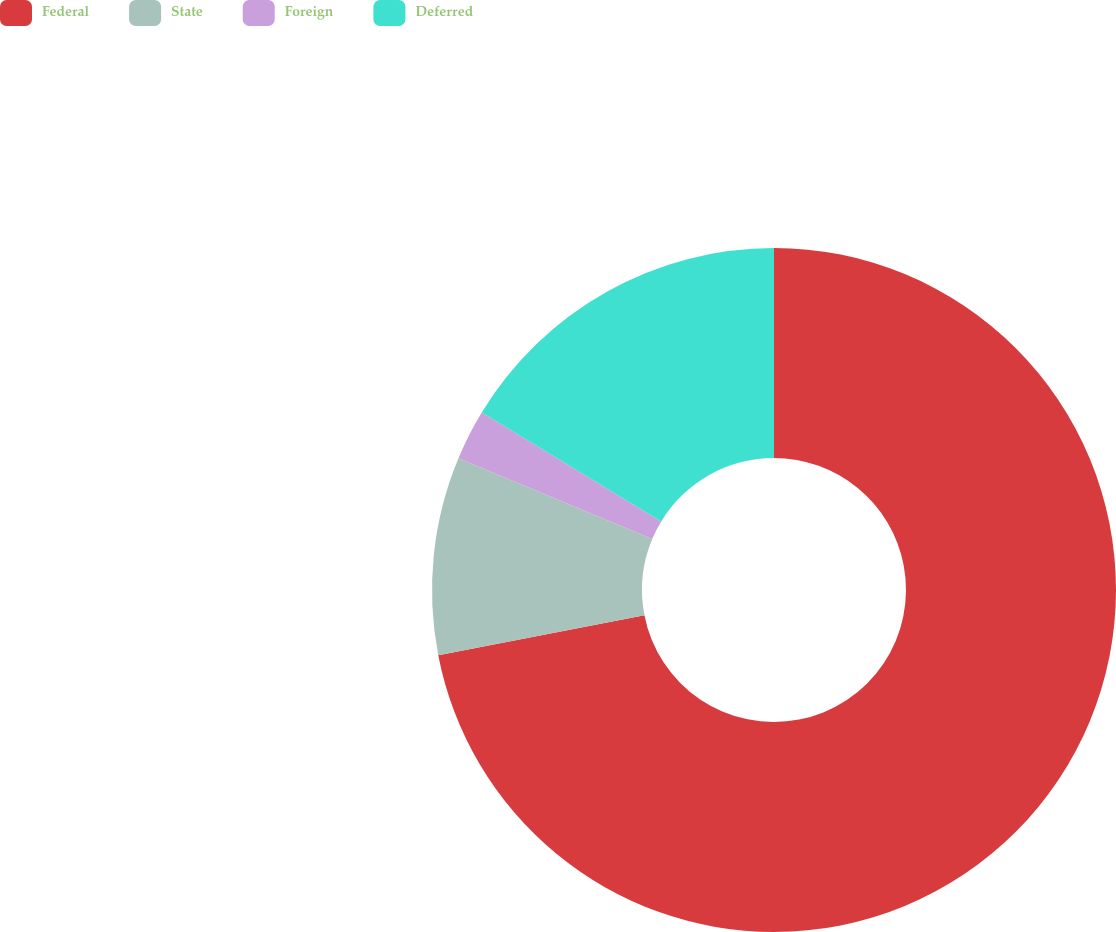Convert chart to OTSL. <chart><loc_0><loc_0><loc_500><loc_500><pie_chart><fcel>Federal<fcel>State<fcel>Foreign<fcel>Deferred<nl><fcel>71.95%<fcel>9.35%<fcel>2.39%<fcel>16.31%<nl></chart> 